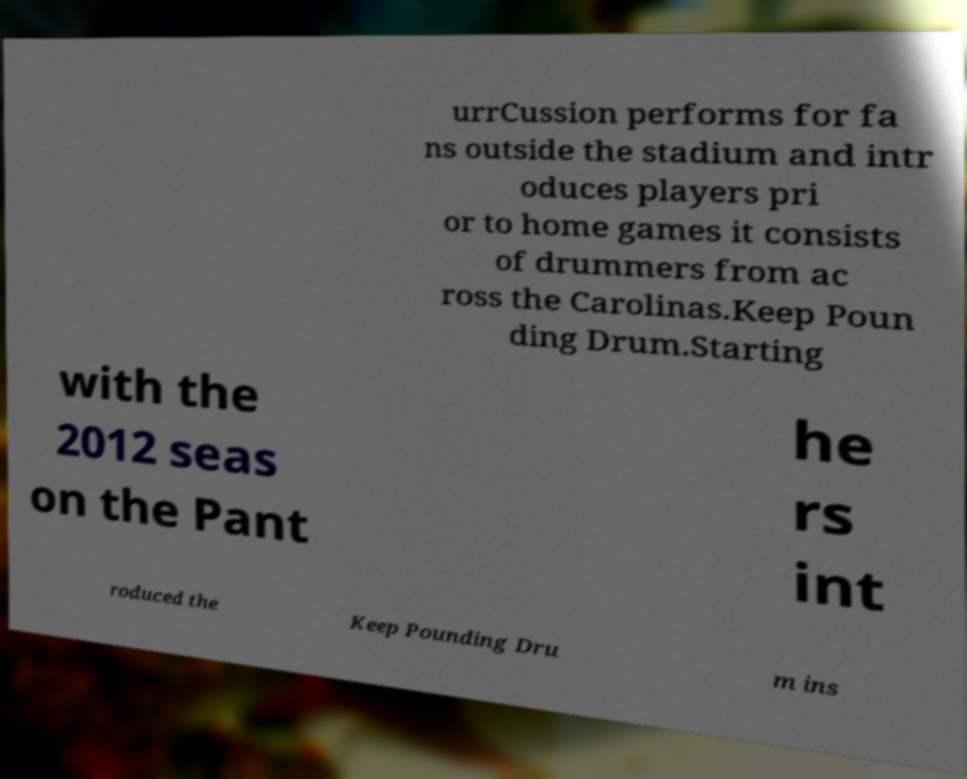For documentation purposes, I need the text within this image transcribed. Could you provide that? urrCussion performs for fa ns outside the stadium and intr oduces players pri or to home games it consists of drummers from ac ross the Carolinas.Keep Poun ding Drum.Starting with the 2012 seas on the Pant he rs int roduced the Keep Pounding Dru m ins 